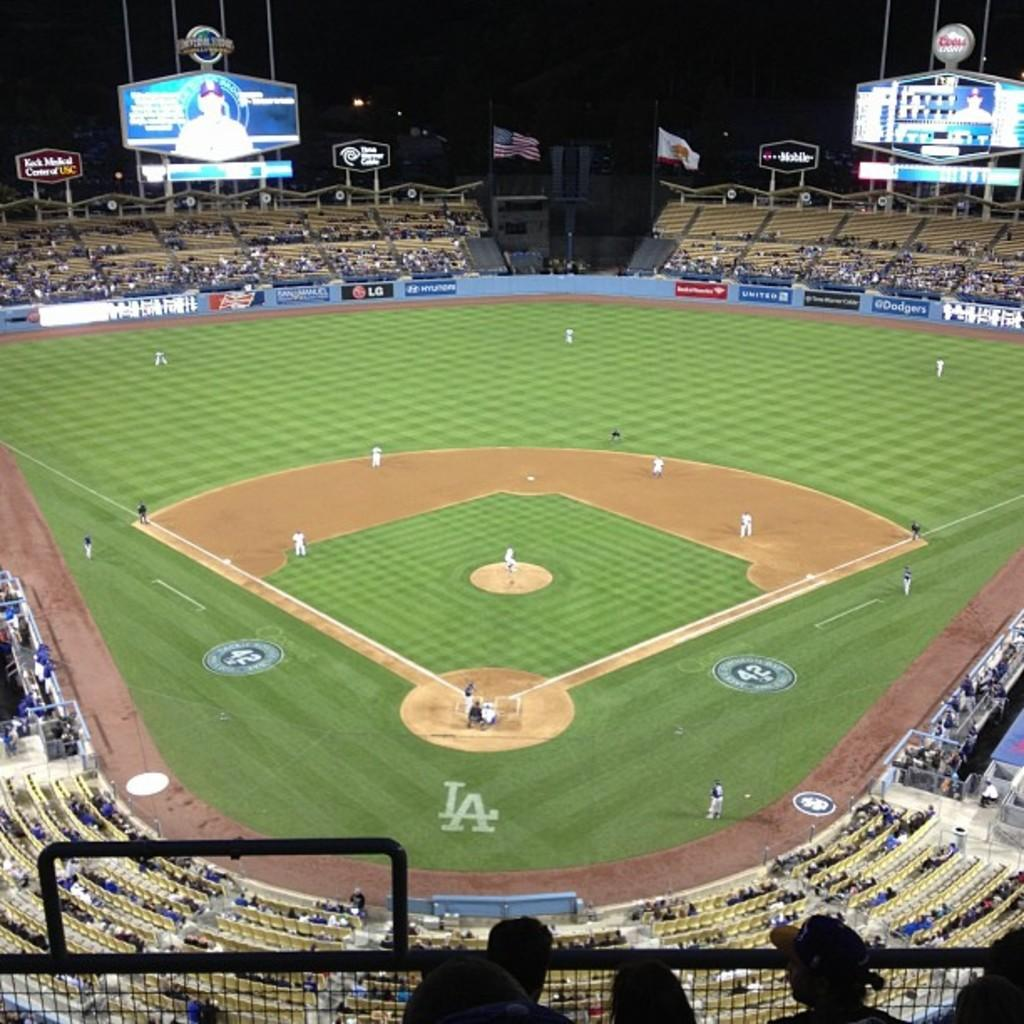Provide a one-sentence caption for the provided image. A baseball field with the letters LA on it and the number 42 on it. 